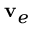Convert formula to latex. <formula><loc_0><loc_0><loc_500><loc_500>{ v } _ { e }</formula> 